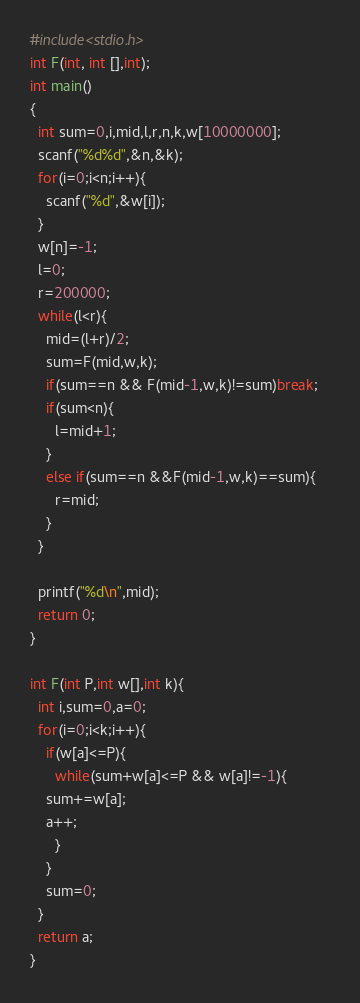<code> <loc_0><loc_0><loc_500><loc_500><_C_>#include<stdio.h>
int F(int, int [],int);
int main()
{
  int sum=0,i,mid,l,r,n,k,w[10000000];
  scanf("%d%d",&n,&k);
  for(i=0;i<n;i++){
    scanf("%d",&w[i]);
  }
  w[n]=-1;
  l=0;
  r=200000;
  while(l<r){
    mid=(l+r)/2;
    sum=F(mid,w,k);
    if(sum==n && F(mid-1,w,k)!=sum)break;   
    if(sum<n){
      l=mid+1;
    }
    else if(sum==n &&F(mid-1,w,k)==sum){
      r=mid;
    }
  }

  printf("%d\n",mid);
  return 0;
}

int F(int P,int w[],int k){
  int i,sum=0,a=0;
  for(i=0;i<k;i++){
    if(w[a]<=P){
      while(sum+w[a]<=P && w[a]!=-1){
	sum+=w[a];
	a++;
      }
    }
    sum=0;
  }
  return a;
}</code> 